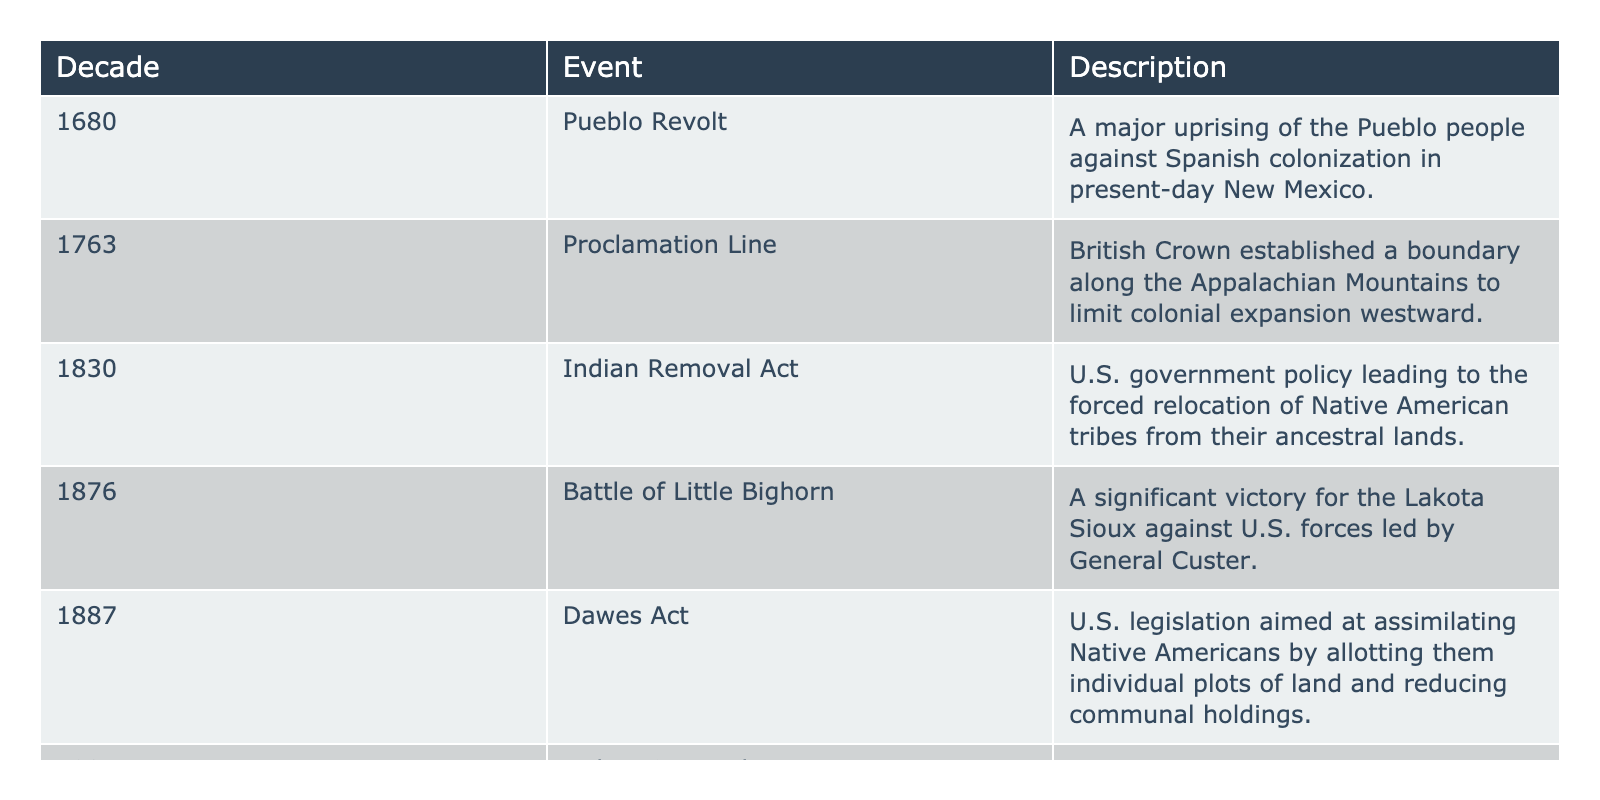What event happened in 1924? The table lists significant events by decade, and under the 1924 row, it shows that the Indian Citizenship Act occurred in that year.
Answer: Indian Citizenship Act Which event occurred just before the Indian Removal Act? To find this, I look at the table for the event listed in 1830, the Indian Removal Act, then check the previous row for the decade which is 1820, and find that the Dawes Act happened in 1887.
Answer: Pueblo Revolt How many events are listed in the table? By counting the number of rows under the events section of the table, I find there are six distinct events listed across different decades.
Answer: 6 Which event represents a significant loss for the Lakota Sioux? The table includes the Battle of Little Bighorn in 1876, which identifies as a significant victory for the Lakota Sioux against U.S. forces, indicating their loss was not recorded as an event in the table.
Answer: True What is the difference between the years of the Dawes Act and the Indian Citizenship Act? I find the Dawes Act in 1887 and the Indian Citizenship Act in 1924. To calculate the difference, I subtract 1887 from 1924: 1924 - 1887 = 37.
Answer: 37 What event reflects Native American opposition to colonization, and in what year did it occur? Looking at the table, the Pueblo Revolt in 1680 is specifically described as a significant uprising against Spanish colonization, indicating resistance by Native Americans.
Answer: 1680 List the events from the earliest to the latest based on their decades. The events are arranged by decade: 1680 - Pueblo Revolt; 1763 - Proclamation Line; 1830 - Indian Removal Act; 1876 - Battle of Little Bighorn; 1887 - Dawes Act; 1924 - Indian Citizenship Act. This chronological order shows the progression of events.
Answer: Pueblo Revolt, Proclamation Line, Indian Removal Act, Battle of Little Bighorn, Dawes Act, Indian Citizenship Act Which of these events relates to the forced relocation of tribes? The Indian Removal Act in 1830 is specifically mentioned in the description as leading to the forced relocation of Native American tribes. Hence, that event correlates directly with the idea of relocation.
Answer: Indian Removal Act 